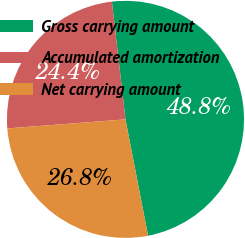Convert chart. <chart><loc_0><loc_0><loc_500><loc_500><pie_chart><fcel>Gross carrying amount<fcel>Accumulated amortization<fcel>Net carrying amount<nl><fcel>48.78%<fcel>24.39%<fcel>26.83%<nl></chart> 